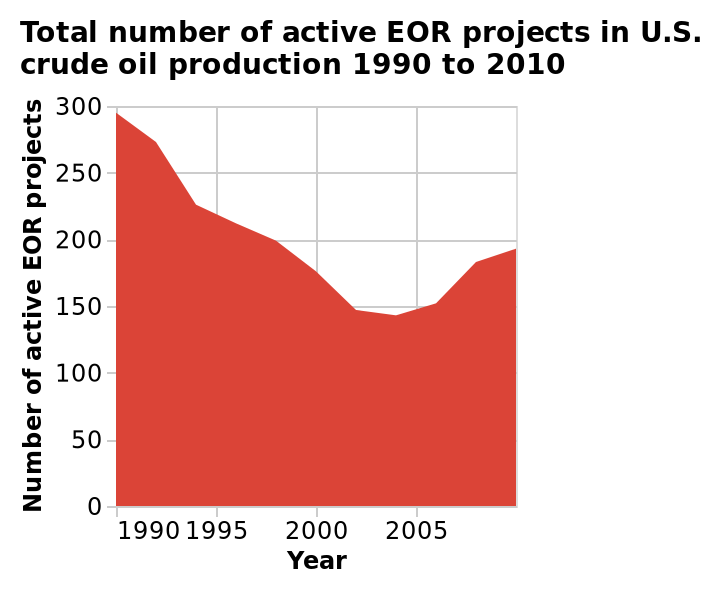<image>
please summary the statistics and relations of the chart The year 1990 shows the largest number of active EOR projects in the US. From 2005-2010 there is an increase in EOR projects in the US. What is the highest number of active EOR projects recorded on the y-axis?  The highest number of active EOR projects recorded on the y-axis is 300. What does the x-axis in the area diagram represent?  The x-axis in the area diagram represents the years from 1990 to 2005. What period of time shows an increase in EOR projects in the US? The period from 2005 to 2010 shows an increase in EOR projects in the US. 